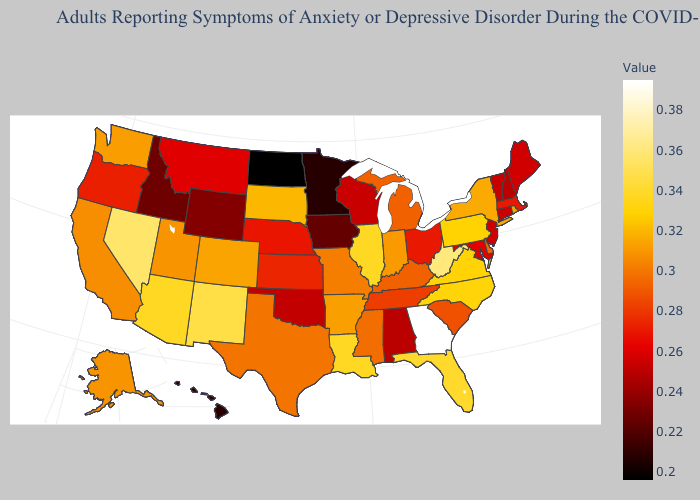Does New Jersey have a higher value than Texas?
Quick response, please. No. Does the map have missing data?
Keep it brief. No. Which states have the lowest value in the Northeast?
Be succinct. New Hampshire. Does West Virginia have a higher value than Georgia?
Keep it brief. No. Does the map have missing data?
Concise answer only. No. 